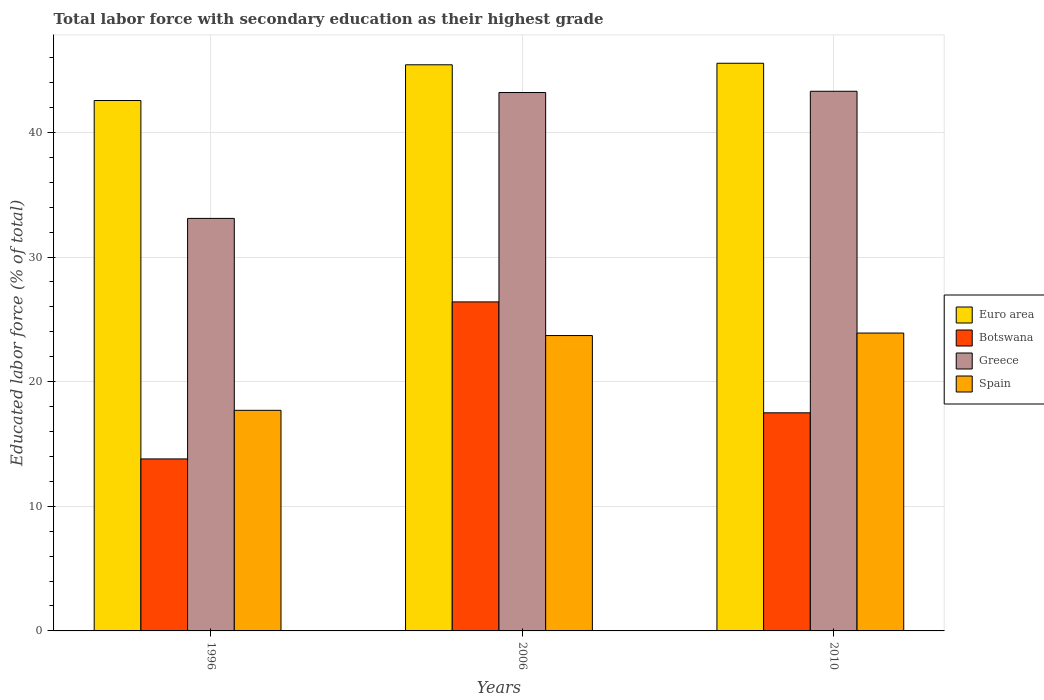How many different coloured bars are there?
Make the answer very short. 4. Are the number of bars on each tick of the X-axis equal?
Keep it short and to the point. Yes. How many bars are there on the 2nd tick from the left?
Give a very brief answer. 4. How many bars are there on the 2nd tick from the right?
Your answer should be very brief. 4. What is the label of the 3rd group of bars from the left?
Give a very brief answer. 2010. In how many cases, is the number of bars for a given year not equal to the number of legend labels?
Keep it short and to the point. 0. What is the percentage of total labor force with primary education in Botswana in 2006?
Give a very brief answer. 26.4. Across all years, what is the maximum percentage of total labor force with primary education in Greece?
Make the answer very short. 43.3. Across all years, what is the minimum percentage of total labor force with primary education in Greece?
Provide a succinct answer. 33.1. In which year was the percentage of total labor force with primary education in Spain maximum?
Provide a short and direct response. 2010. What is the total percentage of total labor force with primary education in Greece in the graph?
Give a very brief answer. 119.6. What is the difference between the percentage of total labor force with primary education in Greece in 2006 and that in 2010?
Offer a very short reply. -0.1. What is the difference between the percentage of total labor force with primary education in Spain in 2006 and the percentage of total labor force with primary education in Botswana in 1996?
Keep it short and to the point. 9.9. What is the average percentage of total labor force with primary education in Euro area per year?
Provide a succinct answer. 44.51. In the year 2006, what is the difference between the percentage of total labor force with primary education in Botswana and percentage of total labor force with primary education in Euro area?
Provide a succinct answer. -19.02. In how many years, is the percentage of total labor force with primary education in Euro area greater than 30 %?
Offer a very short reply. 3. What is the ratio of the percentage of total labor force with primary education in Botswana in 1996 to that in 2010?
Offer a very short reply. 0.79. Is the percentage of total labor force with primary education in Spain in 2006 less than that in 2010?
Make the answer very short. Yes. Is the difference between the percentage of total labor force with primary education in Botswana in 1996 and 2006 greater than the difference between the percentage of total labor force with primary education in Euro area in 1996 and 2006?
Make the answer very short. No. What is the difference between the highest and the second highest percentage of total labor force with primary education in Botswana?
Provide a short and direct response. 8.9. What is the difference between the highest and the lowest percentage of total labor force with primary education in Euro area?
Provide a succinct answer. 2.99. Is the sum of the percentage of total labor force with primary education in Botswana in 1996 and 2006 greater than the maximum percentage of total labor force with primary education in Euro area across all years?
Give a very brief answer. No. What does the 2nd bar from the left in 1996 represents?
Provide a short and direct response. Botswana. What does the 3rd bar from the right in 2006 represents?
Provide a short and direct response. Botswana. Is it the case that in every year, the sum of the percentage of total labor force with primary education in Botswana and percentage of total labor force with primary education in Euro area is greater than the percentage of total labor force with primary education in Spain?
Your answer should be very brief. Yes. How many bars are there?
Give a very brief answer. 12. Are all the bars in the graph horizontal?
Offer a terse response. No. What is the difference between two consecutive major ticks on the Y-axis?
Make the answer very short. 10. Does the graph contain any zero values?
Provide a succinct answer. No. Does the graph contain grids?
Your answer should be very brief. Yes. Where does the legend appear in the graph?
Ensure brevity in your answer.  Center right. How are the legend labels stacked?
Your answer should be compact. Vertical. What is the title of the graph?
Offer a very short reply. Total labor force with secondary education as their highest grade. Does "Mexico" appear as one of the legend labels in the graph?
Make the answer very short. No. What is the label or title of the Y-axis?
Provide a succinct answer. Educated labor force (% of total). What is the Educated labor force (% of total) in Euro area in 1996?
Make the answer very short. 42.56. What is the Educated labor force (% of total) of Botswana in 1996?
Ensure brevity in your answer.  13.8. What is the Educated labor force (% of total) in Greece in 1996?
Provide a short and direct response. 33.1. What is the Educated labor force (% of total) in Spain in 1996?
Offer a terse response. 17.7. What is the Educated labor force (% of total) in Euro area in 2006?
Offer a terse response. 45.42. What is the Educated labor force (% of total) of Botswana in 2006?
Ensure brevity in your answer.  26.4. What is the Educated labor force (% of total) of Greece in 2006?
Ensure brevity in your answer.  43.2. What is the Educated labor force (% of total) in Spain in 2006?
Your response must be concise. 23.7. What is the Educated labor force (% of total) of Euro area in 2010?
Give a very brief answer. 45.55. What is the Educated labor force (% of total) in Botswana in 2010?
Ensure brevity in your answer.  17.5. What is the Educated labor force (% of total) of Greece in 2010?
Provide a short and direct response. 43.3. What is the Educated labor force (% of total) in Spain in 2010?
Your response must be concise. 23.9. Across all years, what is the maximum Educated labor force (% of total) of Euro area?
Keep it short and to the point. 45.55. Across all years, what is the maximum Educated labor force (% of total) of Botswana?
Offer a very short reply. 26.4. Across all years, what is the maximum Educated labor force (% of total) of Greece?
Keep it short and to the point. 43.3. Across all years, what is the maximum Educated labor force (% of total) in Spain?
Offer a terse response. 23.9. Across all years, what is the minimum Educated labor force (% of total) of Euro area?
Your answer should be very brief. 42.56. Across all years, what is the minimum Educated labor force (% of total) of Botswana?
Your answer should be very brief. 13.8. Across all years, what is the minimum Educated labor force (% of total) of Greece?
Your answer should be compact. 33.1. Across all years, what is the minimum Educated labor force (% of total) in Spain?
Keep it short and to the point. 17.7. What is the total Educated labor force (% of total) of Euro area in the graph?
Your response must be concise. 133.53. What is the total Educated labor force (% of total) in Botswana in the graph?
Your response must be concise. 57.7. What is the total Educated labor force (% of total) of Greece in the graph?
Your answer should be very brief. 119.6. What is the total Educated labor force (% of total) in Spain in the graph?
Keep it short and to the point. 65.3. What is the difference between the Educated labor force (% of total) in Euro area in 1996 and that in 2006?
Keep it short and to the point. -2.87. What is the difference between the Educated labor force (% of total) in Spain in 1996 and that in 2006?
Your answer should be compact. -6. What is the difference between the Educated labor force (% of total) of Euro area in 1996 and that in 2010?
Keep it short and to the point. -2.99. What is the difference between the Educated labor force (% of total) in Botswana in 1996 and that in 2010?
Provide a succinct answer. -3.7. What is the difference between the Educated labor force (% of total) in Euro area in 2006 and that in 2010?
Your answer should be compact. -0.12. What is the difference between the Educated labor force (% of total) in Greece in 2006 and that in 2010?
Your response must be concise. -0.1. What is the difference between the Educated labor force (% of total) of Euro area in 1996 and the Educated labor force (% of total) of Botswana in 2006?
Offer a terse response. 16.16. What is the difference between the Educated labor force (% of total) in Euro area in 1996 and the Educated labor force (% of total) in Greece in 2006?
Provide a succinct answer. -0.64. What is the difference between the Educated labor force (% of total) of Euro area in 1996 and the Educated labor force (% of total) of Spain in 2006?
Your response must be concise. 18.86. What is the difference between the Educated labor force (% of total) of Botswana in 1996 and the Educated labor force (% of total) of Greece in 2006?
Your response must be concise. -29.4. What is the difference between the Educated labor force (% of total) in Greece in 1996 and the Educated labor force (% of total) in Spain in 2006?
Provide a short and direct response. 9.4. What is the difference between the Educated labor force (% of total) of Euro area in 1996 and the Educated labor force (% of total) of Botswana in 2010?
Your answer should be compact. 25.06. What is the difference between the Educated labor force (% of total) in Euro area in 1996 and the Educated labor force (% of total) in Greece in 2010?
Offer a terse response. -0.74. What is the difference between the Educated labor force (% of total) of Euro area in 1996 and the Educated labor force (% of total) of Spain in 2010?
Offer a very short reply. 18.66. What is the difference between the Educated labor force (% of total) in Botswana in 1996 and the Educated labor force (% of total) in Greece in 2010?
Offer a terse response. -29.5. What is the difference between the Educated labor force (% of total) in Botswana in 1996 and the Educated labor force (% of total) in Spain in 2010?
Offer a terse response. -10.1. What is the difference between the Educated labor force (% of total) of Euro area in 2006 and the Educated labor force (% of total) of Botswana in 2010?
Make the answer very short. 27.92. What is the difference between the Educated labor force (% of total) in Euro area in 2006 and the Educated labor force (% of total) in Greece in 2010?
Offer a terse response. 2.12. What is the difference between the Educated labor force (% of total) in Euro area in 2006 and the Educated labor force (% of total) in Spain in 2010?
Your response must be concise. 21.52. What is the difference between the Educated labor force (% of total) in Botswana in 2006 and the Educated labor force (% of total) in Greece in 2010?
Give a very brief answer. -16.9. What is the difference between the Educated labor force (% of total) in Greece in 2006 and the Educated labor force (% of total) in Spain in 2010?
Keep it short and to the point. 19.3. What is the average Educated labor force (% of total) of Euro area per year?
Provide a succinct answer. 44.51. What is the average Educated labor force (% of total) in Botswana per year?
Make the answer very short. 19.23. What is the average Educated labor force (% of total) of Greece per year?
Keep it short and to the point. 39.87. What is the average Educated labor force (% of total) in Spain per year?
Your answer should be compact. 21.77. In the year 1996, what is the difference between the Educated labor force (% of total) in Euro area and Educated labor force (% of total) in Botswana?
Your answer should be compact. 28.76. In the year 1996, what is the difference between the Educated labor force (% of total) in Euro area and Educated labor force (% of total) in Greece?
Ensure brevity in your answer.  9.46. In the year 1996, what is the difference between the Educated labor force (% of total) of Euro area and Educated labor force (% of total) of Spain?
Your response must be concise. 24.86. In the year 1996, what is the difference between the Educated labor force (% of total) of Botswana and Educated labor force (% of total) of Greece?
Give a very brief answer. -19.3. In the year 1996, what is the difference between the Educated labor force (% of total) of Greece and Educated labor force (% of total) of Spain?
Provide a succinct answer. 15.4. In the year 2006, what is the difference between the Educated labor force (% of total) in Euro area and Educated labor force (% of total) in Botswana?
Your response must be concise. 19.02. In the year 2006, what is the difference between the Educated labor force (% of total) of Euro area and Educated labor force (% of total) of Greece?
Offer a terse response. 2.22. In the year 2006, what is the difference between the Educated labor force (% of total) in Euro area and Educated labor force (% of total) in Spain?
Offer a terse response. 21.72. In the year 2006, what is the difference between the Educated labor force (% of total) in Botswana and Educated labor force (% of total) in Greece?
Ensure brevity in your answer.  -16.8. In the year 2006, what is the difference between the Educated labor force (% of total) of Botswana and Educated labor force (% of total) of Spain?
Make the answer very short. 2.7. In the year 2010, what is the difference between the Educated labor force (% of total) in Euro area and Educated labor force (% of total) in Botswana?
Ensure brevity in your answer.  28.05. In the year 2010, what is the difference between the Educated labor force (% of total) in Euro area and Educated labor force (% of total) in Greece?
Your answer should be very brief. 2.25. In the year 2010, what is the difference between the Educated labor force (% of total) of Euro area and Educated labor force (% of total) of Spain?
Give a very brief answer. 21.65. In the year 2010, what is the difference between the Educated labor force (% of total) of Botswana and Educated labor force (% of total) of Greece?
Provide a short and direct response. -25.8. In the year 2010, what is the difference between the Educated labor force (% of total) of Greece and Educated labor force (% of total) of Spain?
Offer a very short reply. 19.4. What is the ratio of the Educated labor force (% of total) of Euro area in 1996 to that in 2006?
Provide a succinct answer. 0.94. What is the ratio of the Educated labor force (% of total) of Botswana in 1996 to that in 2006?
Offer a terse response. 0.52. What is the ratio of the Educated labor force (% of total) in Greece in 1996 to that in 2006?
Keep it short and to the point. 0.77. What is the ratio of the Educated labor force (% of total) in Spain in 1996 to that in 2006?
Offer a terse response. 0.75. What is the ratio of the Educated labor force (% of total) in Euro area in 1996 to that in 2010?
Make the answer very short. 0.93. What is the ratio of the Educated labor force (% of total) in Botswana in 1996 to that in 2010?
Offer a very short reply. 0.79. What is the ratio of the Educated labor force (% of total) of Greece in 1996 to that in 2010?
Offer a terse response. 0.76. What is the ratio of the Educated labor force (% of total) of Spain in 1996 to that in 2010?
Keep it short and to the point. 0.74. What is the ratio of the Educated labor force (% of total) of Euro area in 2006 to that in 2010?
Make the answer very short. 1. What is the ratio of the Educated labor force (% of total) of Botswana in 2006 to that in 2010?
Offer a terse response. 1.51. What is the ratio of the Educated labor force (% of total) in Greece in 2006 to that in 2010?
Keep it short and to the point. 1. What is the difference between the highest and the second highest Educated labor force (% of total) in Euro area?
Offer a terse response. 0.12. What is the difference between the highest and the second highest Educated labor force (% of total) of Greece?
Your response must be concise. 0.1. What is the difference between the highest and the lowest Educated labor force (% of total) in Euro area?
Give a very brief answer. 2.99. What is the difference between the highest and the lowest Educated labor force (% of total) in Botswana?
Your answer should be compact. 12.6. What is the difference between the highest and the lowest Educated labor force (% of total) in Greece?
Provide a short and direct response. 10.2. 